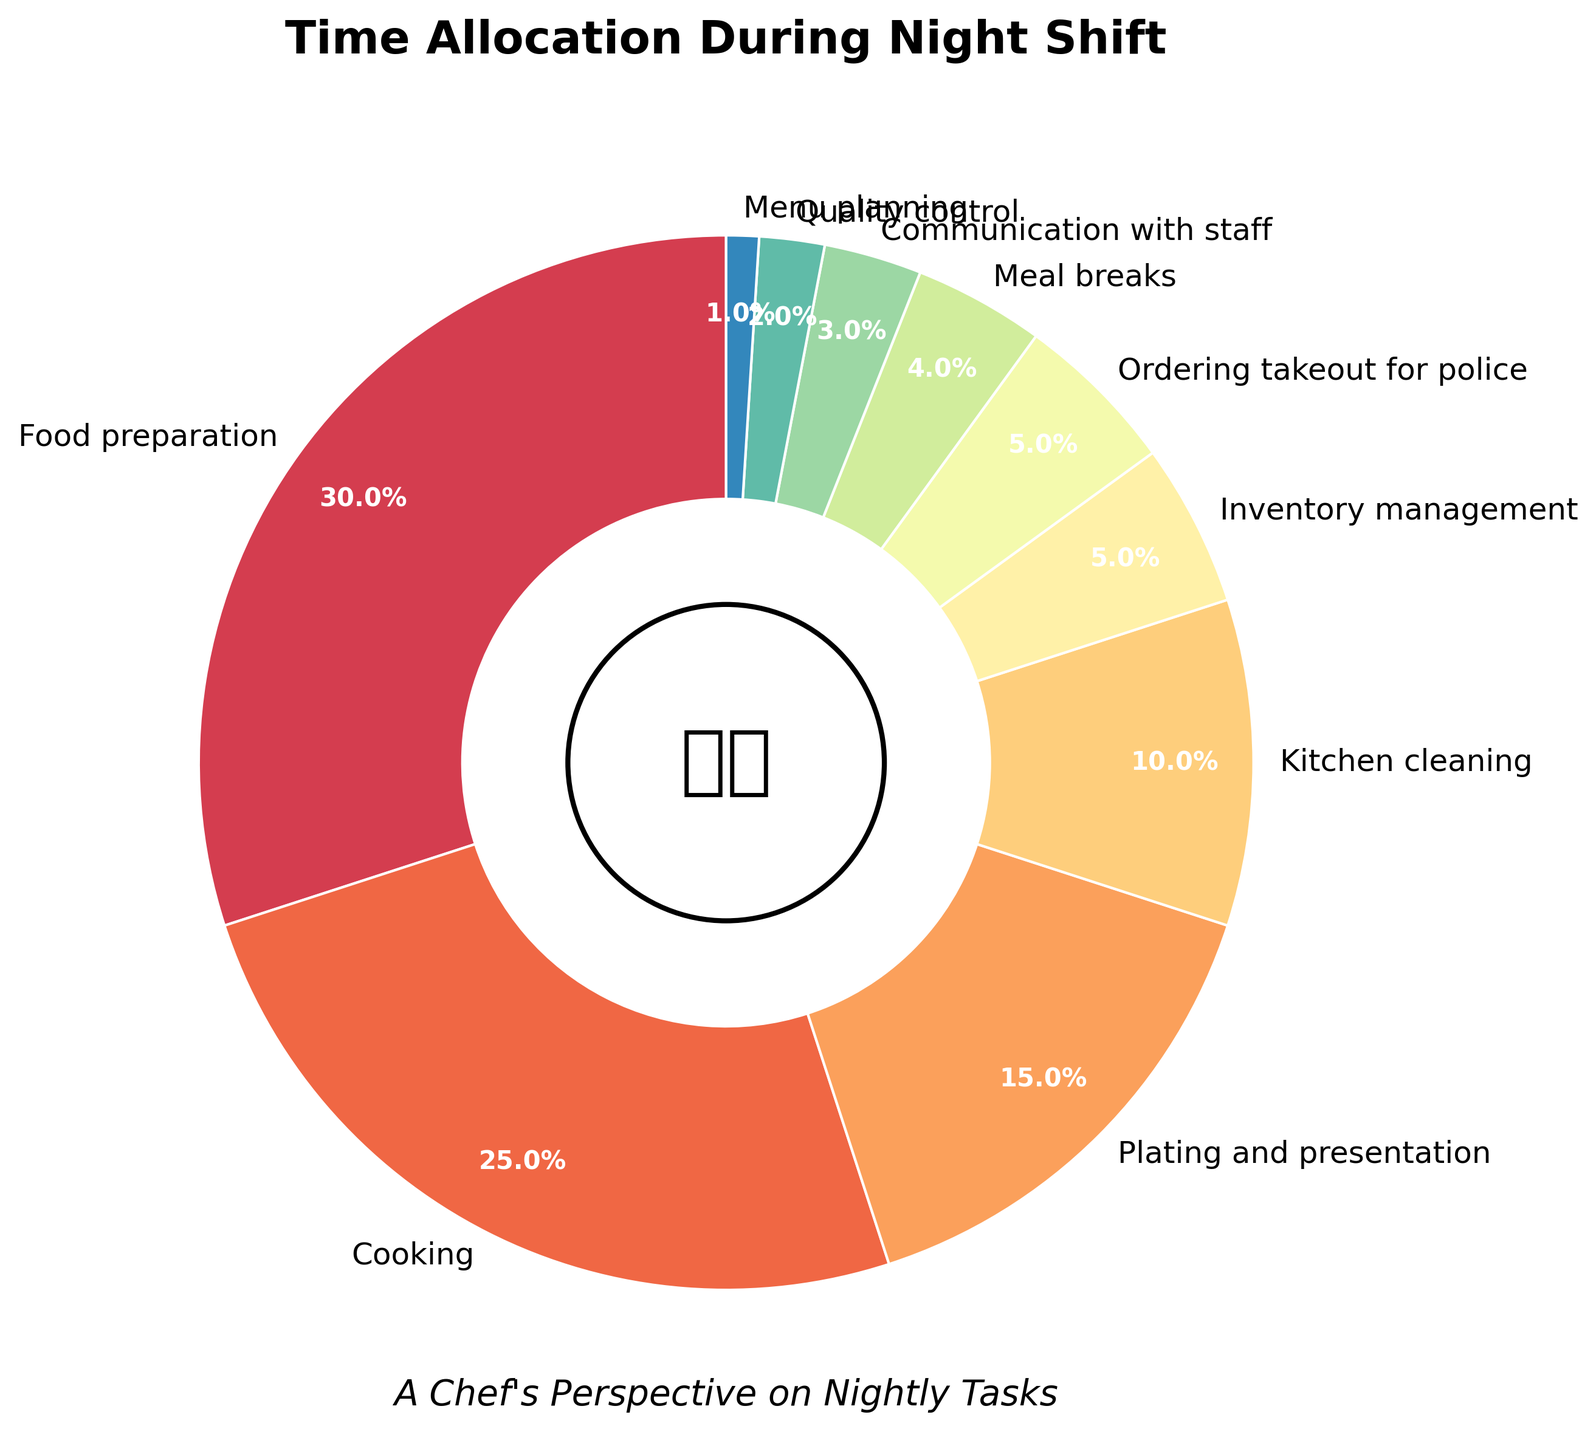What task takes up the most time during the night shift? The task with the largest percentage on the pie chart is food preparation, which occupies 30%.
Answer: Food preparation What percentage of time is spent on cooking compared to kitchen cleaning? Cooking takes 25%, and kitchen cleaning takes 10%. Comparing these, cooking occupies a significantly larger portion of the pie chart.
Answer: 25% vs 10% Which activities combined make up more time than food preparation? Food preparation is 30%. Adding the next highest activities: Cooking (25%), Plating and presentation (15%) gives 25% + 15% = 40%, which is greater than 30%.
Answer: Cooking and Plating and Presentation How much more percentage of time is spent on meal breaks than quality control? Meal breaks take 4%, and quality control takes 2%. The difference is 4% - 2% = 2%.
Answer: 2% Which task takes the second least amount of time? The second least percentage on the pie chart is Quality control at 2%.
Answer: Quality control Is more time spent on menu planning or communication with staff? Menu planning takes 1%, and communication with staff takes 3%. The percentage for communication with staff is higher.
Answer: Communication with staff Are the times allocated for ordering takeout for police and inventory management equal? Both ordering takeout for police and inventory management are shown as taking 5% of the time on the pie chart.
Answer: Yes Combine the percentages of inventory management, ordering takeout for police, and meal breaks. Is it more or less than the percentage for cooking? Inventory management is 5%, ordering takeout for police is 5%, and meal breaks are 4%. The total is 5% + 5% + 4% = 14%, which is less than the 25% allocated for cooking.
Answer: Less Does kitchen cleaning or plating and presentation take up a larger portion of time? Kitchen cleaning is shown as taking 10%, while plating and presentation takes 15%, which is larger.
Answer: Plating and presentation What's the combined percentage of time for communication with staff and menu planning? Communication with staff takes 3%, and menu planning takes 1%. The combined percentage is 3% + 1% = 4%.
Answer: 4% 